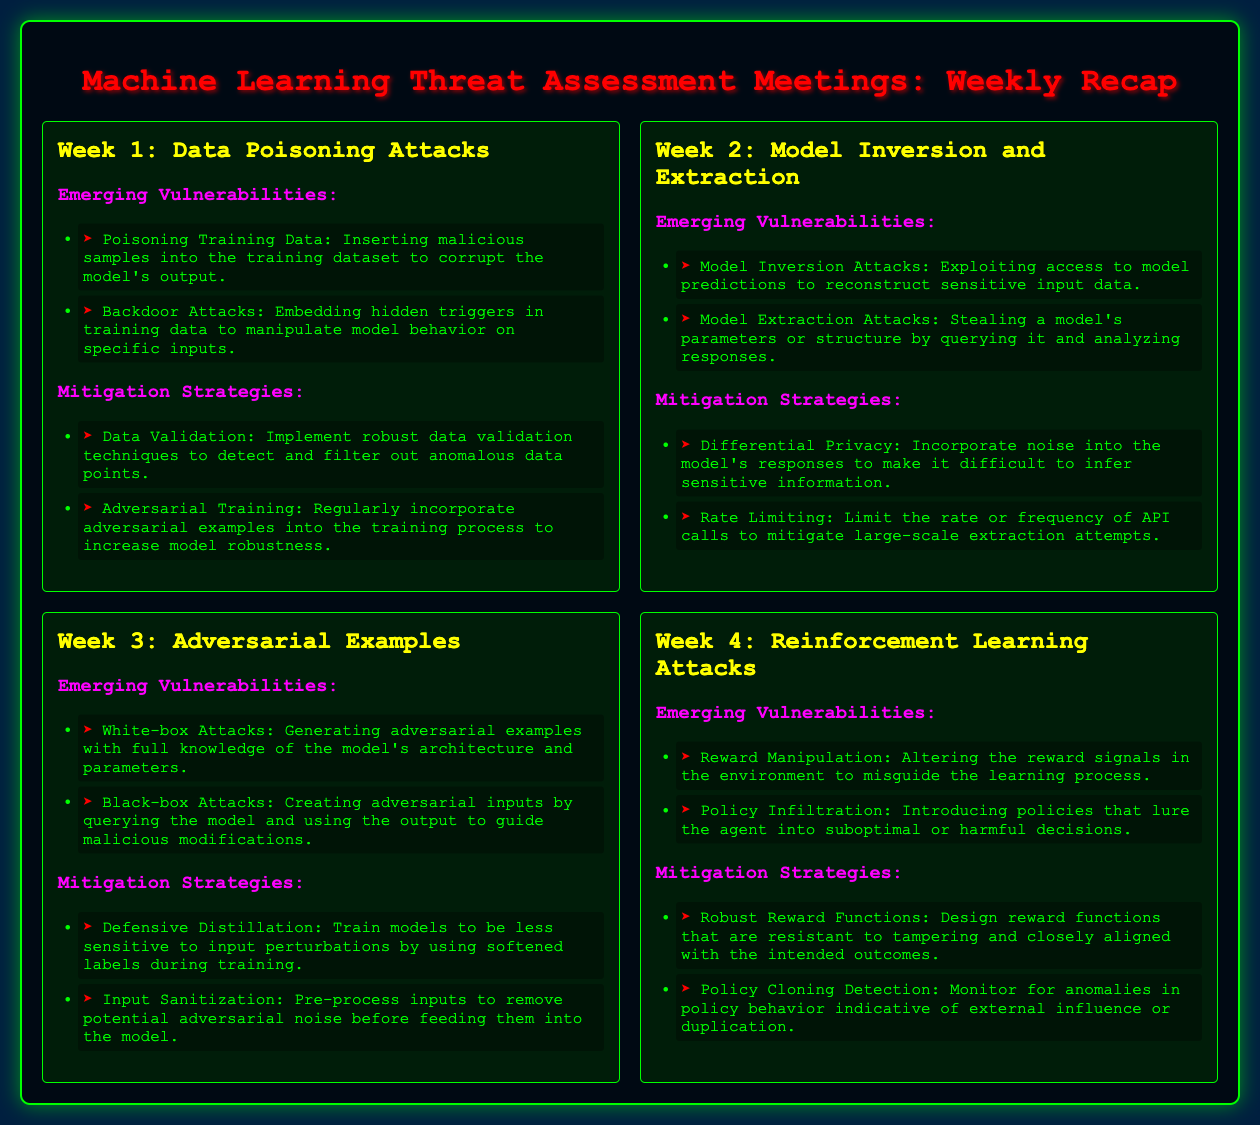What is the title of the document? The title appears at the top of the document, summarizing its content about machine learning threat assessment.
Answer: Machine Learning Threat Assessment Meetings: Weekly Recap What is the focus of Week 1? The week is centered around specific types of attacks on machine learning models and their implications.
Answer: Data Poisoning Attacks What are two types of emerging vulnerabilities listed in Week 2? This can be found in the second week's section on vulnerabilities, detailing specific attack methods.
Answer: Model Inversion Attacks, Model Extraction Attacks What mitigation strategy is suggested for Week 3? The mitigation strategies for adversarial examples include techniques formulated to enhance model resilience.
Answer: Defensive Distillation How many weeks of vulnerabilities and strategies are outlined in the document? The document outlines the threats and strategies over a set period, detailing the number of weeks covered.
Answer: Four weeks What is one of the vulnerabilities related to reinforcement learning mentioned in Week 4? This information can be retrieved from the list of vulnerabilities specific to reinforcement learning threats.
Answer: Reward Manipulation What is the main purpose of the document? Understanding the document's intent helps recognize its objective concerning security measures in machine learning.
Answer: Threat assessment Which strategy from Week 4 is aimed at ensuring reward functions resist tampering? This question seeks a specific mitigation strategy related to reinforcement learning.
Answer: Robust Reward Functions 